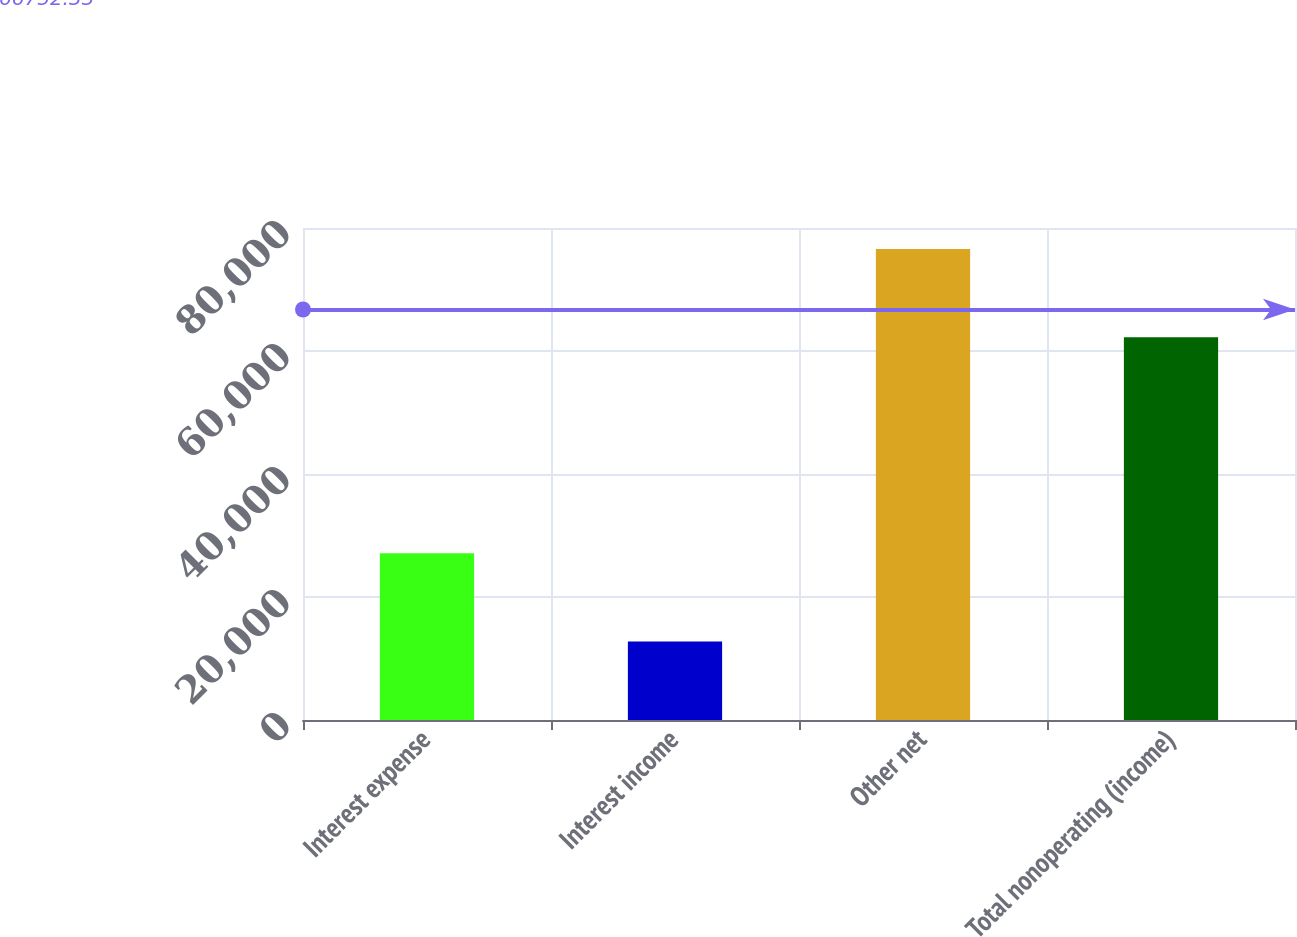Convert chart to OTSL. <chart><loc_0><loc_0><loc_500><loc_500><bar_chart><fcel>Interest expense<fcel>Interest income<fcel>Other net<fcel>Total nonoperating (income)<nl><fcel>27102<fcel>12753<fcel>76597<fcel>62248<nl></chart> 